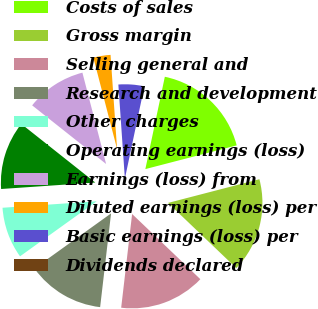<chart> <loc_0><loc_0><loc_500><loc_500><pie_chart><fcel>Costs of sales<fcel>Gross margin<fcel>Selling general and<fcel>Research and development<fcel>Other charges<fcel>Operating earnings (loss)<fcel>Earnings (loss) from<fcel>Diluted earnings (loss) per<fcel>Basic earnings (loss) per<fcel>Dividends declared<nl><fcel>17.65%<fcel>16.18%<fcel>14.71%<fcel>13.24%<fcel>8.82%<fcel>11.76%<fcel>10.29%<fcel>2.94%<fcel>4.41%<fcel>0.0%<nl></chart> 